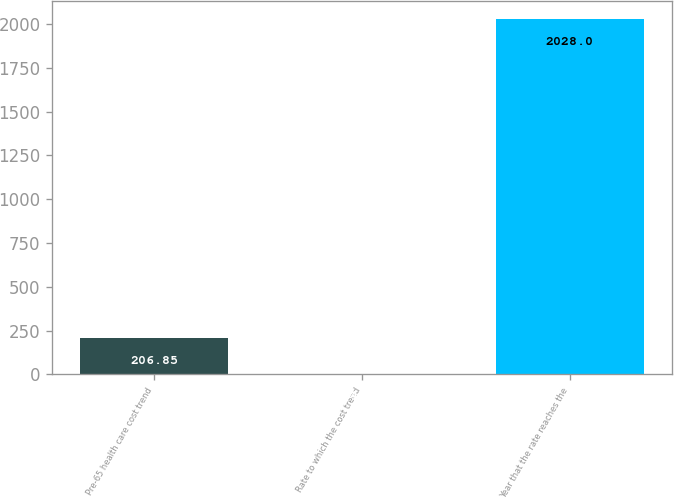<chart> <loc_0><loc_0><loc_500><loc_500><bar_chart><fcel>Pre-65 health care cost trend<fcel>Rate to which the cost trend<fcel>Year that the rate reaches the<nl><fcel>206.85<fcel>4.5<fcel>2028<nl></chart> 